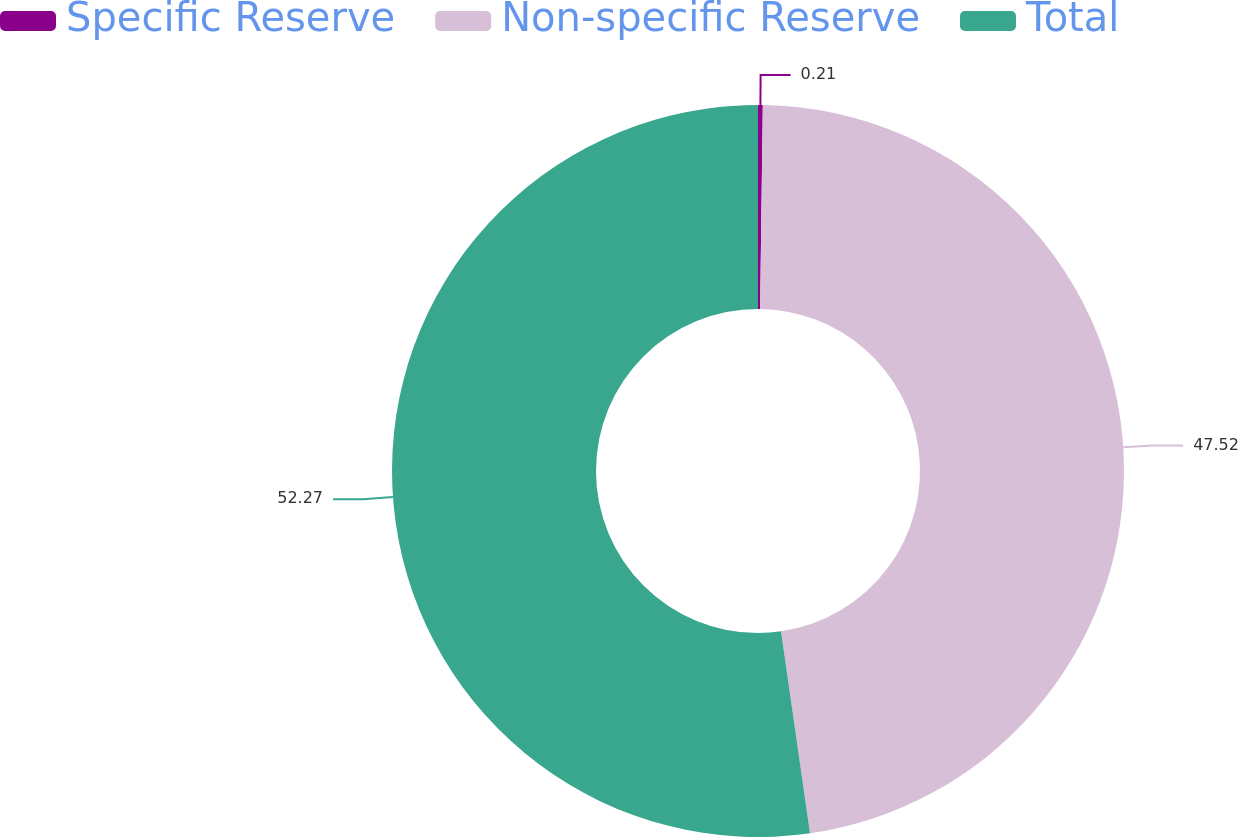<chart> <loc_0><loc_0><loc_500><loc_500><pie_chart><fcel>Specific Reserve<fcel>Non-specific Reserve<fcel>Total<nl><fcel>0.21%<fcel>47.52%<fcel>52.27%<nl></chart> 